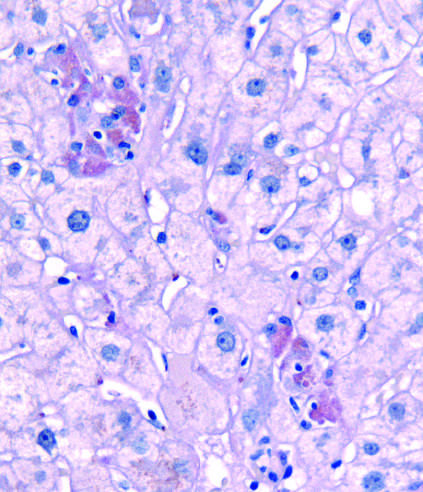when does pas-d , periodic acid-schiff stain?
Answer the question using a single word or phrase. After diastase digestion 